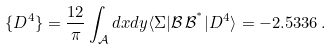<formula> <loc_0><loc_0><loc_500><loc_500>\{ D ^ { 4 } \} = \frac { 1 2 } { \pi } \int _ { \mathcal { A } } d x d y \langle \Sigma | \mathcal { B } \, \mathcal { B } ^ { ^ { * } } | D ^ { 4 } \rangle = - 2 . 5 3 3 6 \, .</formula> 